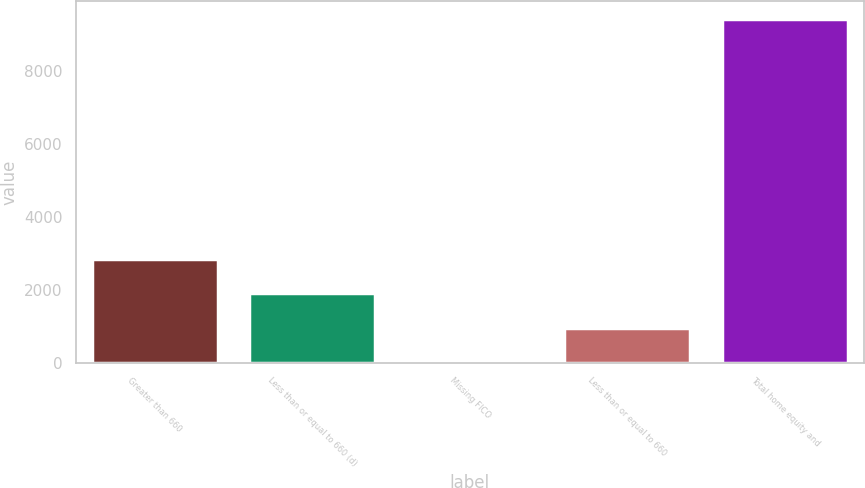Convert chart to OTSL. <chart><loc_0><loc_0><loc_500><loc_500><bar_chart><fcel>Greater than 660<fcel>Less than or equal to 660 (d)<fcel>Missing FICO<fcel>Less than or equal to 660<fcel>Total home equity and<nl><fcel>2840.8<fcel>1900.2<fcel>19<fcel>959.6<fcel>9425<nl></chart> 